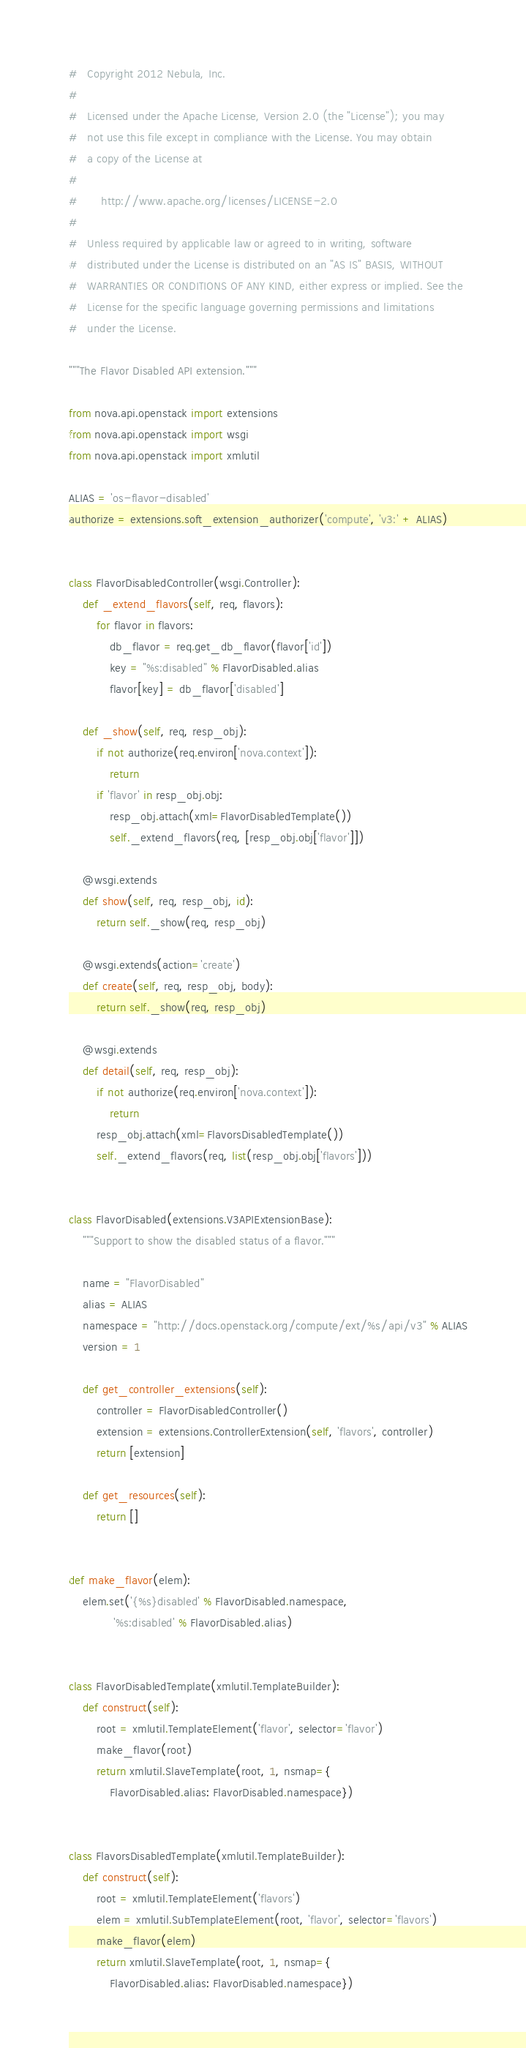<code> <loc_0><loc_0><loc_500><loc_500><_Python_>#   Copyright 2012 Nebula, Inc.
#
#   Licensed under the Apache License, Version 2.0 (the "License"); you may
#   not use this file except in compliance with the License. You may obtain
#   a copy of the License at
#
#       http://www.apache.org/licenses/LICENSE-2.0
#
#   Unless required by applicable law or agreed to in writing, software
#   distributed under the License is distributed on an "AS IS" BASIS, WITHOUT
#   WARRANTIES OR CONDITIONS OF ANY KIND, either express or implied. See the
#   License for the specific language governing permissions and limitations
#   under the License.

"""The Flavor Disabled API extension."""

from nova.api.openstack import extensions
from nova.api.openstack import wsgi
from nova.api.openstack import xmlutil

ALIAS = 'os-flavor-disabled'
authorize = extensions.soft_extension_authorizer('compute', 'v3:' + ALIAS)


class FlavorDisabledController(wsgi.Controller):
    def _extend_flavors(self, req, flavors):
        for flavor in flavors:
            db_flavor = req.get_db_flavor(flavor['id'])
            key = "%s:disabled" % FlavorDisabled.alias
            flavor[key] = db_flavor['disabled']

    def _show(self, req, resp_obj):
        if not authorize(req.environ['nova.context']):
            return
        if 'flavor' in resp_obj.obj:
            resp_obj.attach(xml=FlavorDisabledTemplate())
            self._extend_flavors(req, [resp_obj.obj['flavor']])

    @wsgi.extends
    def show(self, req, resp_obj, id):
        return self._show(req, resp_obj)

    @wsgi.extends(action='create')
    def create(self, req, resp_obj, body):
        return self._show(req, resp_obj)

    @wsgi.extends
    def detail(self, req, resp_obj):
        if not authorize(req.environ['nova.context']):
            return
        resp_obj.attach(xml=FlavorsDisabledTemplate())
        self._extend_flavors(req, list(resp_obj.obj['flavors']))


class FlavorDisabled(extensions.V3APIExtensionBase):
    """Support to show the disabled status of a flavor."""

    name = "FlavorDisabled"
    alias = ALIAS
    namespace = "http://docs.openstack.org/compute/ext/%s/api/v3" % ALIAS
    version = 1

    def get_controller_extensions(self):
        controller = FlavorDisabledController()
        extension = extensions.ControllerExtension(self, 'flavors', controller)
        return [extension]

    def get_resources(self):
        return []


def make_flavor(elem):
    elem.set('{%s}disabled' % FlavorDisabled.namespace,
             '%s:disabled' % FlavorDisabled.alias)


class FlavorDisabledTemplate(xmlutil.TemplateBuilder):
    def construct(self):
        root = xmlutil.TemplateElement('flavor', selector='flavor')
        make_flavor(root)
        return xmlutil.SlaveTemplate(root, 1, nsmap={
            FlavorDisabled.alias: FlavorDisabled.namespace})


class FlavorsDisabledTemplate(xmlutil.TemplateBuilder):
    def construct(self):
        root = xmlutil.TemplateElement('flavors')
        elem = xmlutil.SubTemplateElement(root, 'flavor', selector='flavors')
        make_flavor(elem)
        return xmlutil.SlaveTemplate(root, 1, nsmap={
            FlavorDisabled.alias: FlavorDisabled.namespace})
</code> 